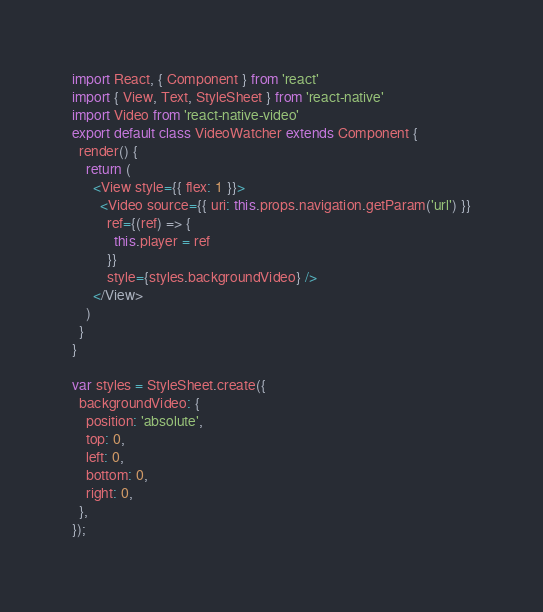<code> <loc_0><loc_0><loc_500><loc_500><_JavaScript_>import React, { Component } from 'react'
import { View, Text, StyleSheet } from 'react-native'
import Video from 'react-native-video'
export default class VideoWatcher extends Component {
  render() {
    return (
      <View style={{ flex: 1 }}>
        <Video source={{ uri: this.props.navigation.getParam('url') }}
          ref={(ref) => {
            this.player = ref
          }}
          style={styles.backgroundVideo} />
      </View>
    )
  }
}

var styles = StyleSheet.create({
  backgroundVideo: {
    position: 'absolute',
    top: 0,
    left: 0,
    bottom: 0,
    right: 0,
  },
});
</code> 